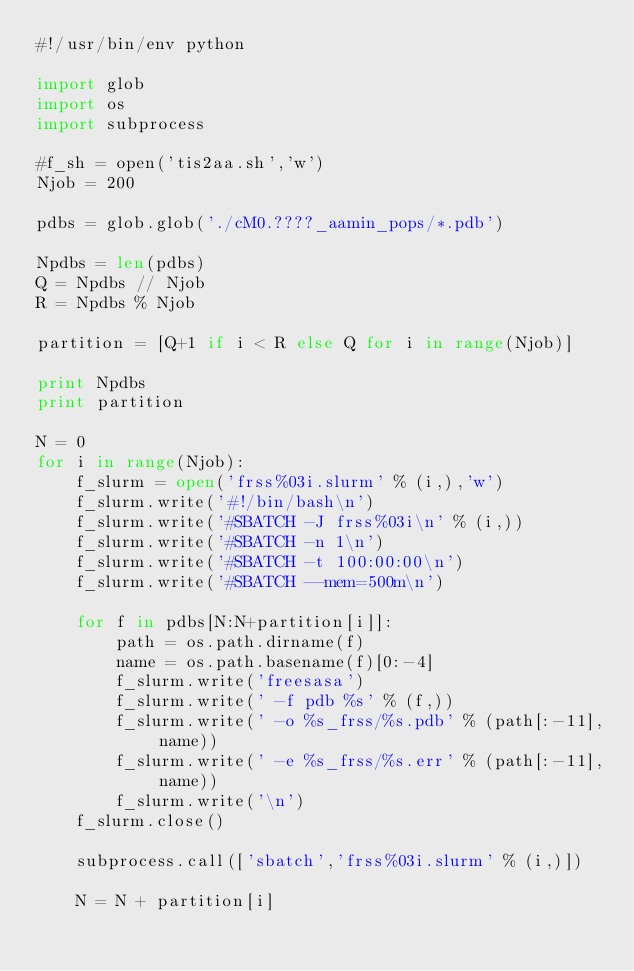Convert code to text. <code><loc_0><loc_0><loc_500><loc_500><_Python_>#!/usr/bin/env python

import glob
import os
import subprocess

#f_sh = open('tis2aa.sh','w')
Njob = 200

pdbs = glob.glob('./cM0.????_aamin_pops/*.pdb')

Npdbs = len(pdbs)
Q = Npdbs // Njob
R = Npdbs % Njob

partition = [Q+1 if i < R else Q for i in range(Njob)]

print Npdbs
print partition

N = 0
for i in range(Njob):
    f_slurm = open('frss%03i.slurm' % (i,),'w')
    f_slurm.write('#!/bin/bash\n')
    f_slurm.write('#SBATCH -J frss%03i\n' % (i,))
    f_slurm.write('#SBATCH -n 1\n')
    f_slurm.write('#SBATCH -t 100:00:00\n')
    f_slurm.write('#SBATCH --mem=500m\n')

    for f in pdbs[N:N+partition[i]]:
        path = os.path.dirname(f)
        name = os.path.basename(f)[0:-4]
        f_slurm.write('freesasa')
        f_slurm.write(' -f pdb %s' % (f,))
        f_slurm.write(' -o %s_frss/%s.pdb' % (path[:-11], name))
        f_slurm.write(' -e %s_frss/%s.err' % (path[:-11], name))
        f_slurm.write('\n')
    f_slurm.close()

    subprocess.call(['sbatch','frss%03i.slurm' % (i,)])

    N = N + partition[i]
</code> 